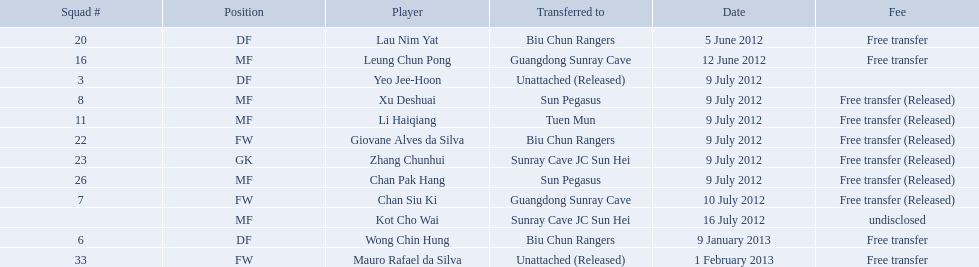On what dates were there non released free transfers? 5 June 2012, 12 June 2012, 9 January 2013, 1 February 2013. On which of these were the players transferred to another team? 5 June 2012, 12 June 2012, 9 January 2013. Help me parse the entirety of this table. {'header': ['Squad #', 'Position', 'Player', 'Transferred to', 'Date', 'Fee'], 'rows': [['20', 'DF', 'Lau Nim Yat', 'Biu Chun Rangers', '5 June 2012', 'Free transfer'], ['16', 'MF', 'Leung Chun Pong', 'Guangdong Sunray Cave', '12 June 2012', 'Free transfer'], ['3', 'DF', 'Yeo Jee-Hoon', 'Unattached (Released)', '9 July 2012', ''], ['8', 'MF', 'Xu Deshuai', 'Sun Pegasus', '9 July 2012', 'Free transfer (Released)'], ['11', 'MF', 'Li Haiqiang', 'Tuen Mun', '9 July 2012', 'Free transfer (Released)'], ['22', 'FW', 'Giovane Alves da Silva', 'Biu Chun Rangers', '9 July 2012', 'Free transfer (Released)'], ['23', 'GK', 'Zhang Chunhui', 'Sunray Cave JC Sun Hei', '9 July 2012', 'Free transfer (Released)'], ['26', 'MF', 'Chan Pak Hang', 'Sun Pegasus', '9 July 2012', 'Free transfer (Released)'], ['7', 'FW', 'Chan Siu Ki', 'Guangdong Sunray Cave', '10 July 2012', 'Free transfer (Released)'], ['', 'MF', 'Kot Cho Wai', 'Sunray Cave JC Sun Hei', '16 July 2012', 'undisclosed'], ['6', 'DF', 'Wong Chin Hung', 'Biu Chun Rangers', '9 January 2013', 'Free transfer'], ['33', 'FW', 'Mauro Rafael da Silva', 'Unattached (Released)', '1 February 2013', 'Free transfer']]} Which of these were the transfers to biu chun rangers? 5 June 2012, 9 January 2013. On which of those dated did they receive a df? 9 January 2013. 